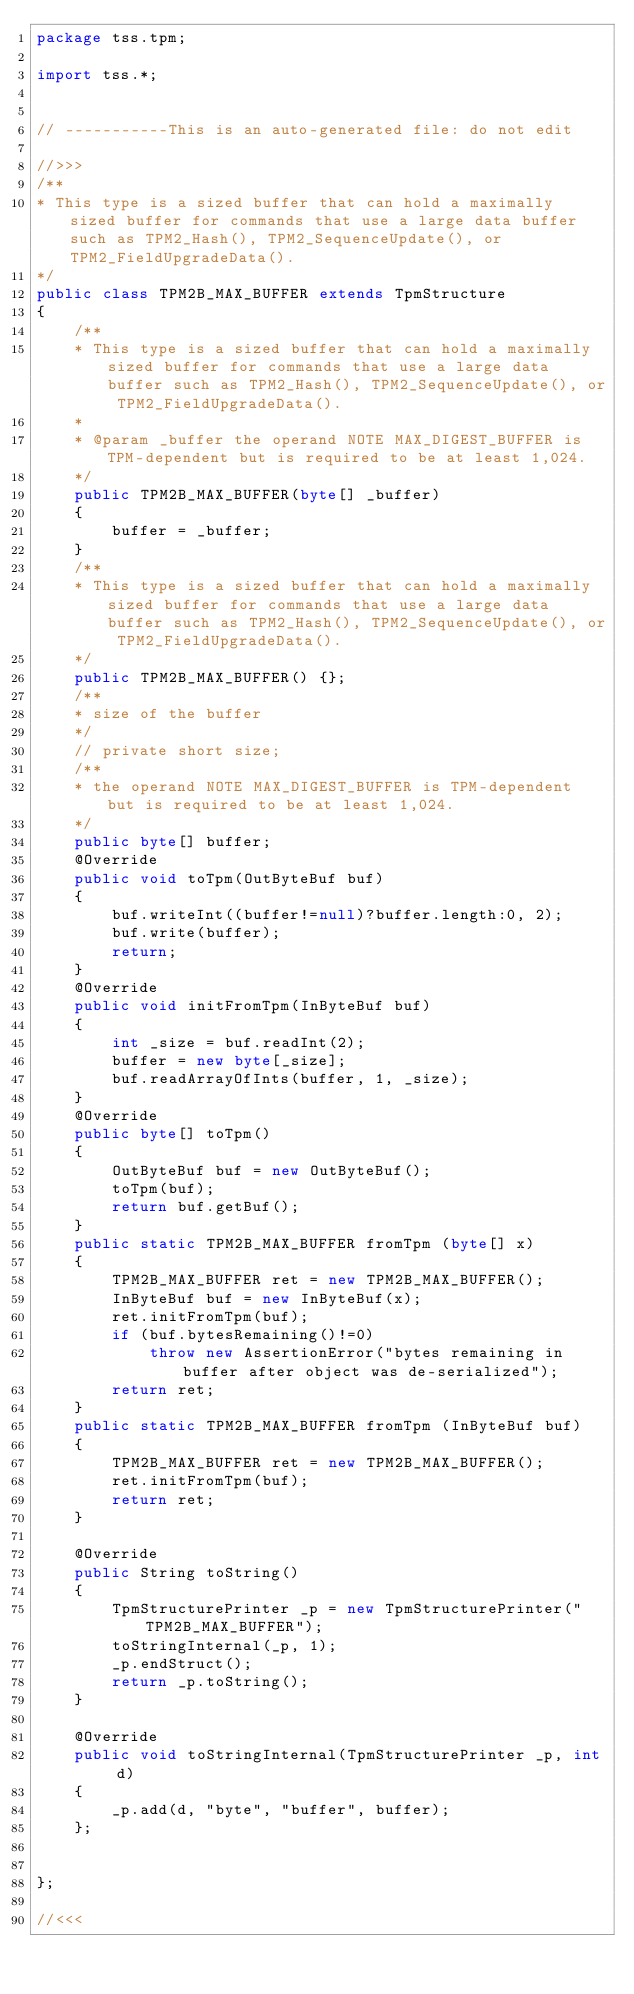Convert code to text. <code><loc_0><loc_0><loc_500><loc_500><_Java_>package tss.tpm;

import tss.*;


// -----------This is an auto-generated file: do not edit

//>>>
/**
* This type is a sized buffer that can hold a maximally sized buffer for commands that use a large data buffer such as TPM2_Hash(), TPM2_SequenceUpdate(), or TPM2_FieldUpgradeData().
*/
public class TPM2B_MAX_BUFFER extends TpmStructure
{
    /**
    * This type is a sized buffer that can hold a maximally sized buffer for commands that use a large data buffer such as TPM2_Hash(), TPM2_SequenceUpdate(), or TPM2_FieldUpgradeData().
    * 
    * @param _buffer the operand NOTE MAX_DIGEST_BUFFER is TPM-dependent but is required to be at least 1,024.
    */
    public TPM2B_MAX_BUFFER(byte[] _buffer)
    {
        buffer = _buffer;
    }
    /**
    * This type is a sized buffer that can hold a maximally sized buffer for commands that use a large data buffer such as TPM2_Hash(), TPM2_SequenceUpdate(), or TPM2_FieldUpgradeData().
    */
    public TPM2B_MAX_BUFFER() {};
    /**
    * size of the buffer
    */
    // private short size;
    /**
    * the operand NOTE MAX_DIGEST_BUFFER is TPM-dependent but is required to be at least 1,024.
    */
    public byte[] buffer;
    @Override
    public void toTpm(OutByteBuf buf) 
    {
        buf.writeInt((buffer!=null)?buffer.length:0, 2);
        buf.write(buffer);
        return;
    }
    @Override
    public void initFromTpm(InByteBuf buf)
    {
        int _size = buf.readInt(2);
        buffer = new byte[_size];
        buf.readArrayOfInts(buffer, 1, _size);
    }
    @Override
    public byte[] toTpm() 
    {
        OutByteBuf buf = new OutByteBuf();
        toTpm(buf);
        return buf.getBuf();
    }
    public static TPM2B_MAX_BUFFER fromTpm (byte[] x) 
    {
        TPM2B_MAX_BUFFER ret = new TPM2B_MAX_BUFFER();
        InByteBuf buf = new InByteBuf(x);
        ret.initFromTpm(buf);
        if (buf.bytesRemaining()!=0)
            throw new AssertionError("bytes remaining in buffer after object was de-serialized");
        return ret;
    }
    public static TPM2B_MAX_BUFFER fromTpm (InByteBuf buf) 
    {
        TPM2B_MAX_BUFFER ret = new TPM2B_MAX_BUFFER();
        ret.initFromTpm(buf);
        return ret;
    }
    
    @Override
    public String toString()
    {
        TpmStructurePrinter _p = new TpmStructurePrinter("TPM2B_MAX_BUFFER");
        toStringInternal(_p, 1);
        _p.endStruct();
        return _p.toString();
    }
    
    @Override
    public void toStringInternal(TpmStructurePrinter _p, int d)
    {
        _p.add(d, "byte", "buffer", buffer);
    };
    
    
};

//<<<

</code> 